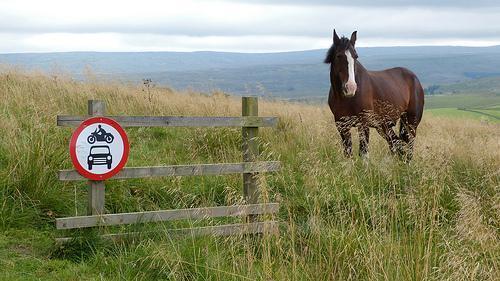How many horses are there?
Give a very brief answer. 1. 